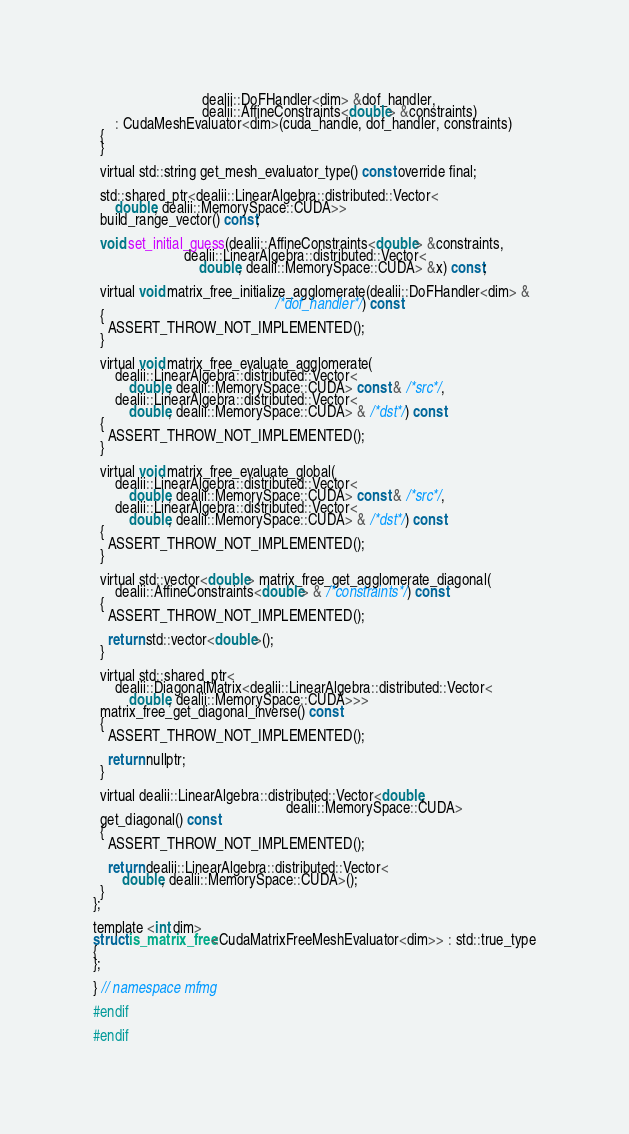Convert code to text. <code><loc_0><loc_0><loc_500><loc_500><_Cuda_>                              dealii::DoFHandler<dim> &dof_handler,
                              dealii::AffineConstraints<double> &constraints)
      : CudaMeshEvaluator<dim>(cuda_handle, dof_handler, constraints)
  {
  }

  virtual std::string get_mesh_evaluator_type() const override final;

  std::shared_ptr<dealii::LinearAlgebra::distributed::Vector<
      double, dealii::MemorySpace::CUDA>>
  build_range_vector() const;

  void set_initial_guess(dealii::AffineConstraints<double> &constraints,
                         dealii::LinearAlgebra::distributed::Vector<
                             double, dealii::MemorySpace::CUDA> &x) const;

  virtual void matrix_free_initialize_agglomerate(dealii::DoFHandler<dim> &
                                                  /*dof_handler*/) const
  {
    ASSERT_THROW_NOT_IMPLEMENTED();
  }

  virtual void matrix_free_evaluate_agglomerate(
      dealii::LinearAlgebra::distributed::Vector<
          double, dealii::MemorySpace::CUDA> const & /*src*/,
      dealii::LinearAlgebra::distributed::Vector<
          double, dealii::MemorySpace::CUDA> & /*dst*/) const
  {
    ASSERT_THROW_NOT_IMPLEMENTED();
  }

  virtual void matrix_free_evaluate_global(
      dealii::LinearAlgebra::distributed::Vector<
          double, dealii::MemorySpace::CUDA> const & /*src*/,
      dealii::LinearAlgebra::distributed::Vector<
          double, dealii::MemorySpace::CUDA> & /*dst*/) const
  {
    ASSERT_THROW_NOT_IMPLEMENTED();
  }

  virtual std::vector<double> matrix_free_get_agglomerate_diagonal(
      dealii::AffineConstraints<double> & /*constraints*/) const
  {
    ASSERT_THROW_NOT_IMPLEMENTED();

    return std::vector<double>();
  }

  virtual std::shared_ptr<
      dealii::DiagonalMatrix<dealii::LinearAlgebra::distributed::Vector<
          double, dealii::MemorySpace::CUDA>>>
  matrix_free_get_diagonal_inverse() const
  {
    ASSERT_THROW_NOT_IMPLEMENTED();

    return nullptr;
  }

  virtual dealii::LinearAlgebra::distributed::Vector<double,
                                                     dealii::MemorySpace::CUDA>
  get_diagonal() const
  {
    ASSERT_THROW_NOT_IMPLEMENTED();

    return dealii::LinearAlgebra::distributed::Vector<
        double, dealii::MemorySpace::CUDA>();
  }
};

template <int dim>
struct is_matrix_free<CudaMatrixFreeMeshEvaluator<dim>> : std::true_type
{
};

} // namespace mfmg

#endif

#endif
</code> 